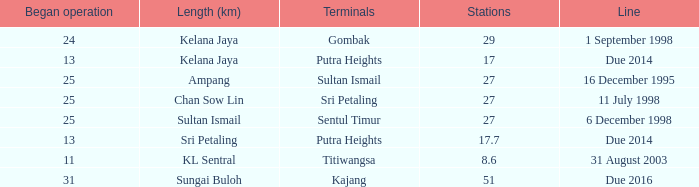When is the earliest began operation with a length of sultan ismail and over 27 stations? None. Could you help me parse every detail presented in this table? {'header': ['Began operation', 'Length (km)', 'Terminals', 'Stations', 'Line'], 'rows': [['24', 'Kelana Jaya', 'Gombak', '29', '1 September 1998'], ['13', 'Kelana Jaya', 'Putra Heights', '17', 'Due 2014'], ['25', 'Ampang', 'Sultan Ismail', '27', '16 December 1995'], ['25', 'Chan Sow Lin', 'Sri Petaling', '27', '11 July 1998'], ['25', 'Sultan Ismail', 'Sentul Timur', '27', '6 December 1998'], ['13', 'Sri Petaling', 'Putra Heights', '17.7', 'Due 2014'], ['11', 'KL Sentral', 'Titiwangsa', '8.6', '31 August 2003'], ['31', 'Sungai Buloh', 'Kajang', '51', 'Due 2016']]} 